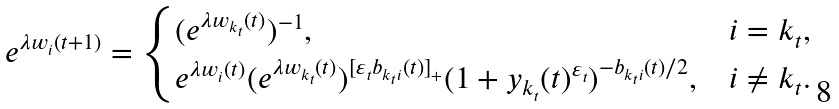<formula> <loc_0><loc_0><loc_500><loc_500>e ^ { \lambda w _ { i } ( t + 1 ) } = \begin{cases} ( e ^ { \lambda w _ { k _ { t } } ( t ) } ) ^ { - 1 } , & i = k _ { t } , \\ e ^ { \lambda w _ { i } ( t ) } ( e ^ { \lambda w _ { k _ { t } } ( t ) } ) ^ { [ \varepsilon _ { t } b _ { k _ { t } i } ( t ) ] _ { + } } ( 1 + y _ { k _ { t } } ( t ) ^ { \varepsilon _ { t } } ) ^ { - b _ { k _ { t } i } ( t ) / 2 } , & i \neq k _ { t } . \end{cases}</formula> 